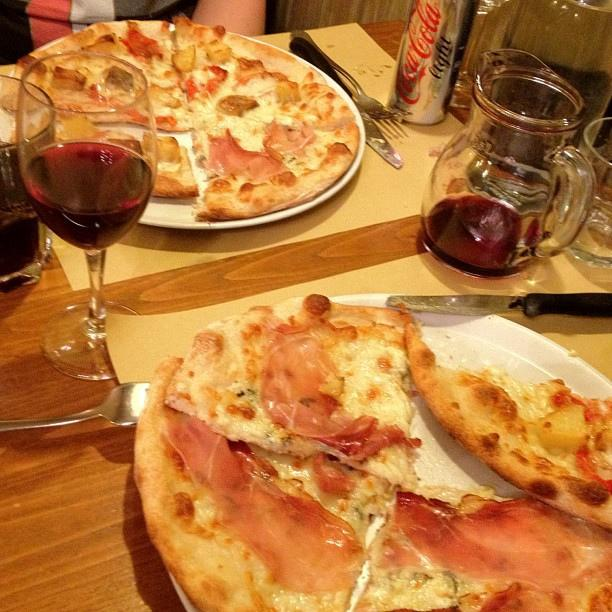Where would you most likely see this type of pizza served with wine? Please explain your reasoning. italy. Pizza and wine are an italian meal. 